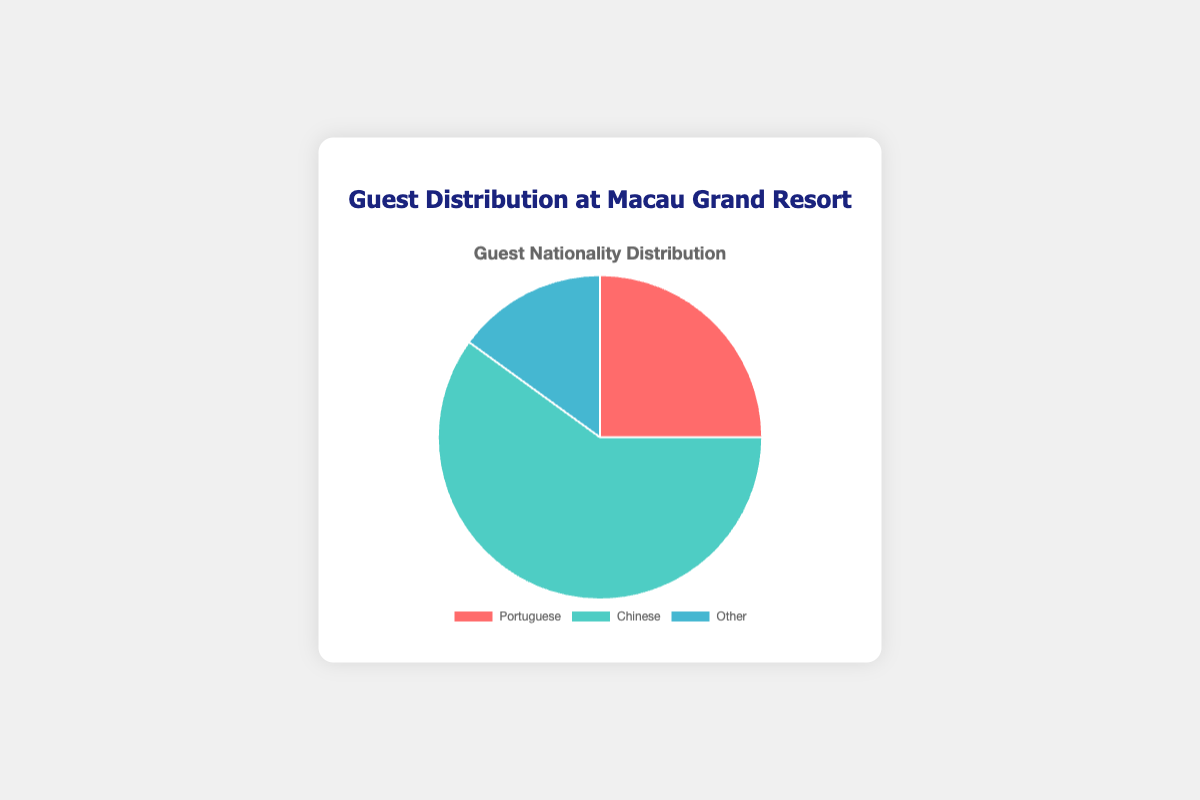What is the percentage of Portuguese guests at the Macau Grand Resort? The figure shows that the slice representing Portuguese guests is labeled with a percentage of 25%.
Answer: 25% What is the combined percentage of Portuguese and Other guests? The data points for Portuguese and Other guests are 25% and 15%, respectively. Adding these percentages gives 25% + 15% = 40%.
Answer: 40% Which nationality has the highest percentage of guests at the Macau Grand Resort? The figure has three slices for three nationalities, with the largest slice labeled as 'Chinese' having 60%.
Answer: Chinese How much larger is the percentage of Chinese guests compared to Portuguese guests? The percentage of Chinese guests is 60%, and the percentage of Portuguese guests is 25%. The difference is 60% - 25% = 35%.
Answer: 35% If the total number of guests is 200, how many guests belong to the 'Other' category? The percentage for 'Other' is 15%. Therefore, the number of guests is (15/100) * 200 = 30.
Answer: 30 What is the difference in percentage between the nationality with the smallest and largest guest representation? The smallest percentage is for 'Other' with 15%, and the largest is for 'Chinese' with 60%. The difference is 60% - 15% = 45%.
Answer: 45% Which color represents the 'Other' nationality in the chart? The 'Other' nationality is shown as the smallest slice and is colored in blue, based on the figure.
Answer: Blue If 10 more Portuguese guests arrive, increasing their percentage by an additional 5%, what will be their new percentage? The initial percentage of Portuguese guests is 25%. Adding an additional 5% gives 25% + 5% = 30%.
Answer: 30% What is the ratio of Chinese guests to Other guests? The percentage of Chinese guests is 60%, and the percentage of Other guests is 15%. The ratio is 60% : 15%, which simplifies to 4:1.
Answer: 4:1 What fraction of the pie chart represents guests classified as 'Other'? The 'Other' category represents 15% of the total, which is equivalent to the fraction 15/100 or 3/20.
Answer: 3/20 